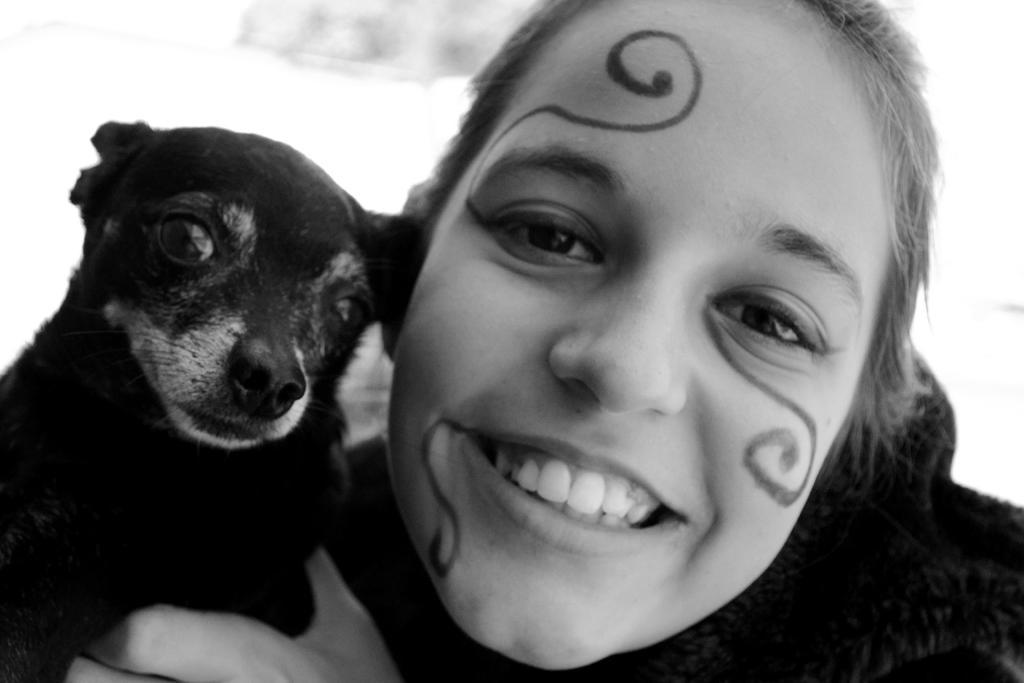How would you summarize this image in a sentence or two? As we can see in the image there is a woman holding black color dog. 